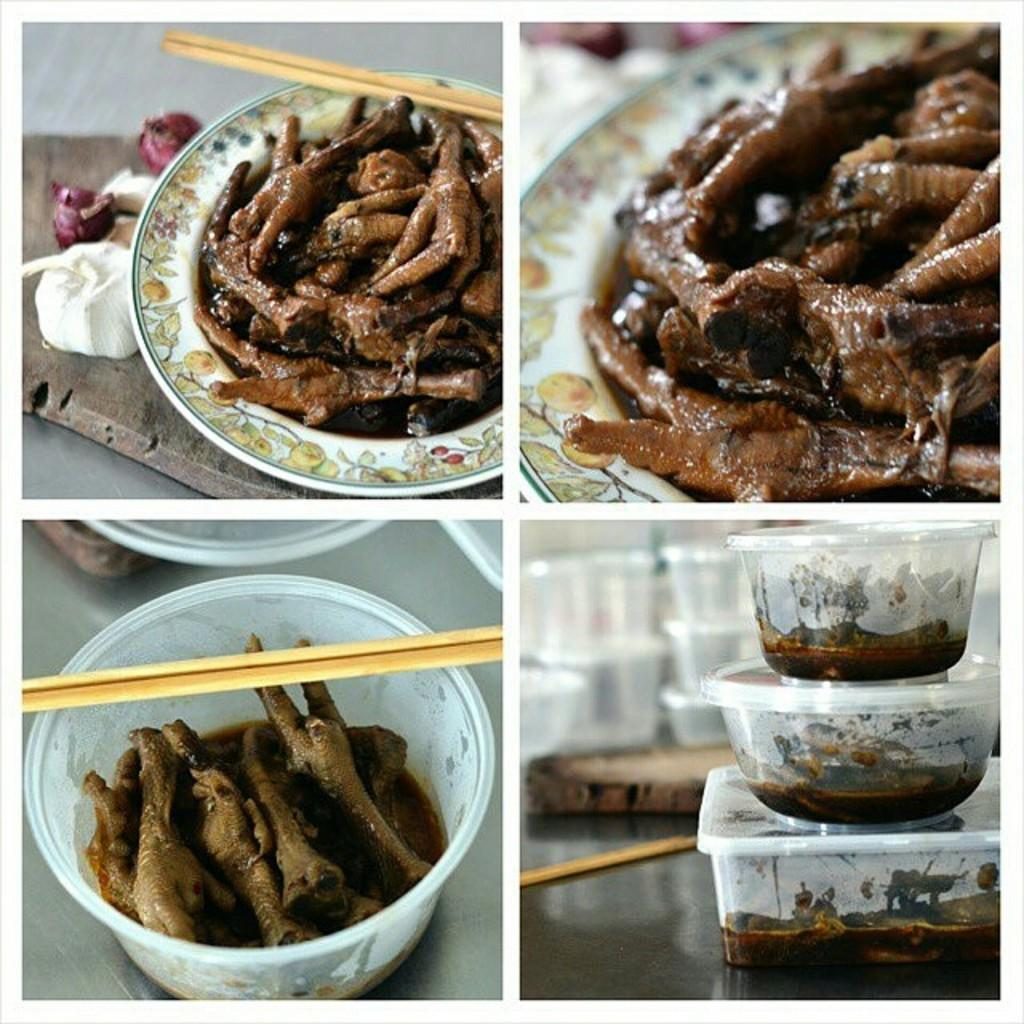What type of artwork is depicted in the image? The image is a collage. What can be seen on the plates and boxes in the image? There are various dishes in plates and boxes in the image. What utensils are present in the image? There are chopsticks in the image. What is the wooden board used for in the image? The wooden board is likely used as a serving surface for the dishes. What other types of food can be seen in the image? There are other food varieties in the image. Is there a note with the current temperature in the image? There is no note with the current temperature present in the image. Can you see a pocket in the image? There is no pocket visible in the image. 